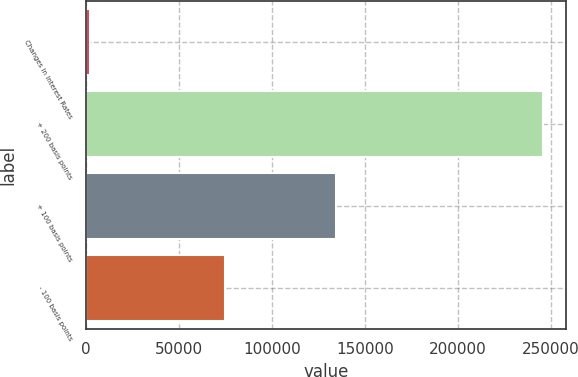<chart> <loc_0><loc_0><loc_500><loc_500><bar_chart><fcel>Changes in Interest Rates<fcel>+ 200 basis points<fcel>+ 100 basis points<fcel>- 100 basis points<nl><fcel>2014<fcel>246028<fcel>134393<fcel>74634<nl></chart> 